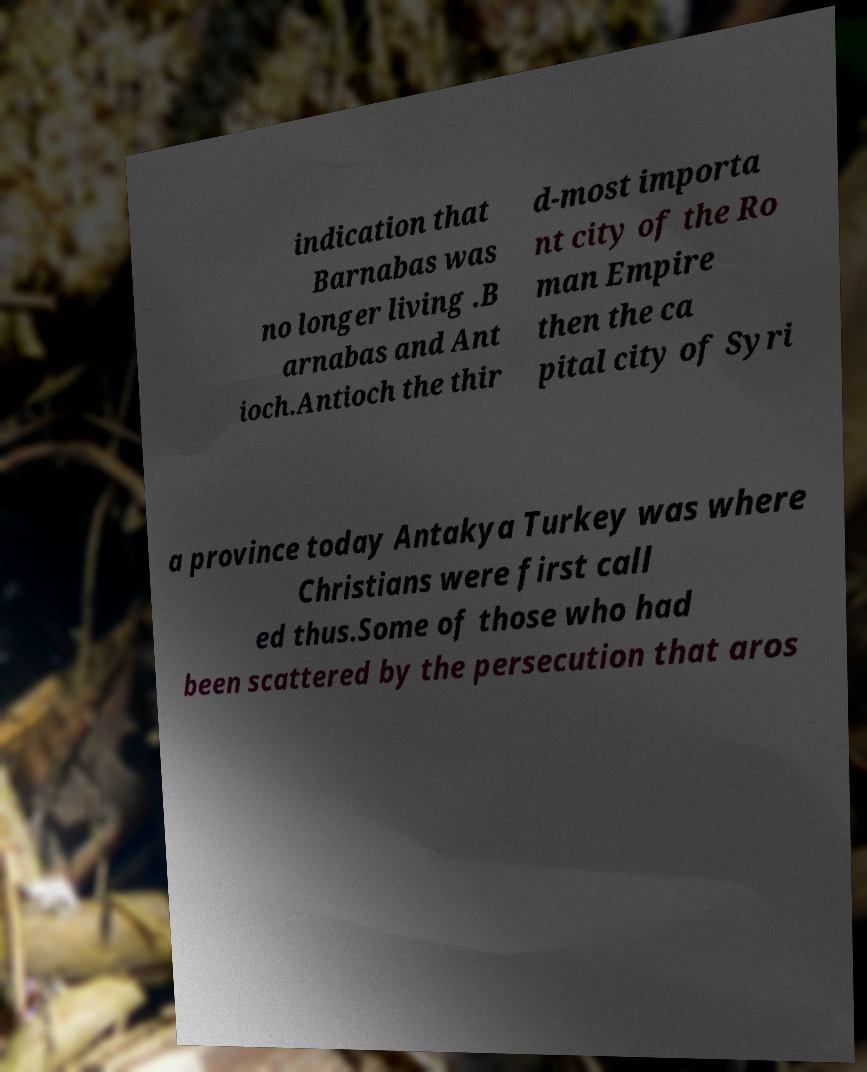Please read and relay the text visible in this image. What does it say? indication that Barnabas was no longer living .B arnabas and Ant ioch.Antioch the thir d-most importa nt city of the Ro man Empire then the ca pital city of Syri a province today Antakya Turkey was where Christians were first call ed thus.Some of those who had been scattered by the persecution that aros 